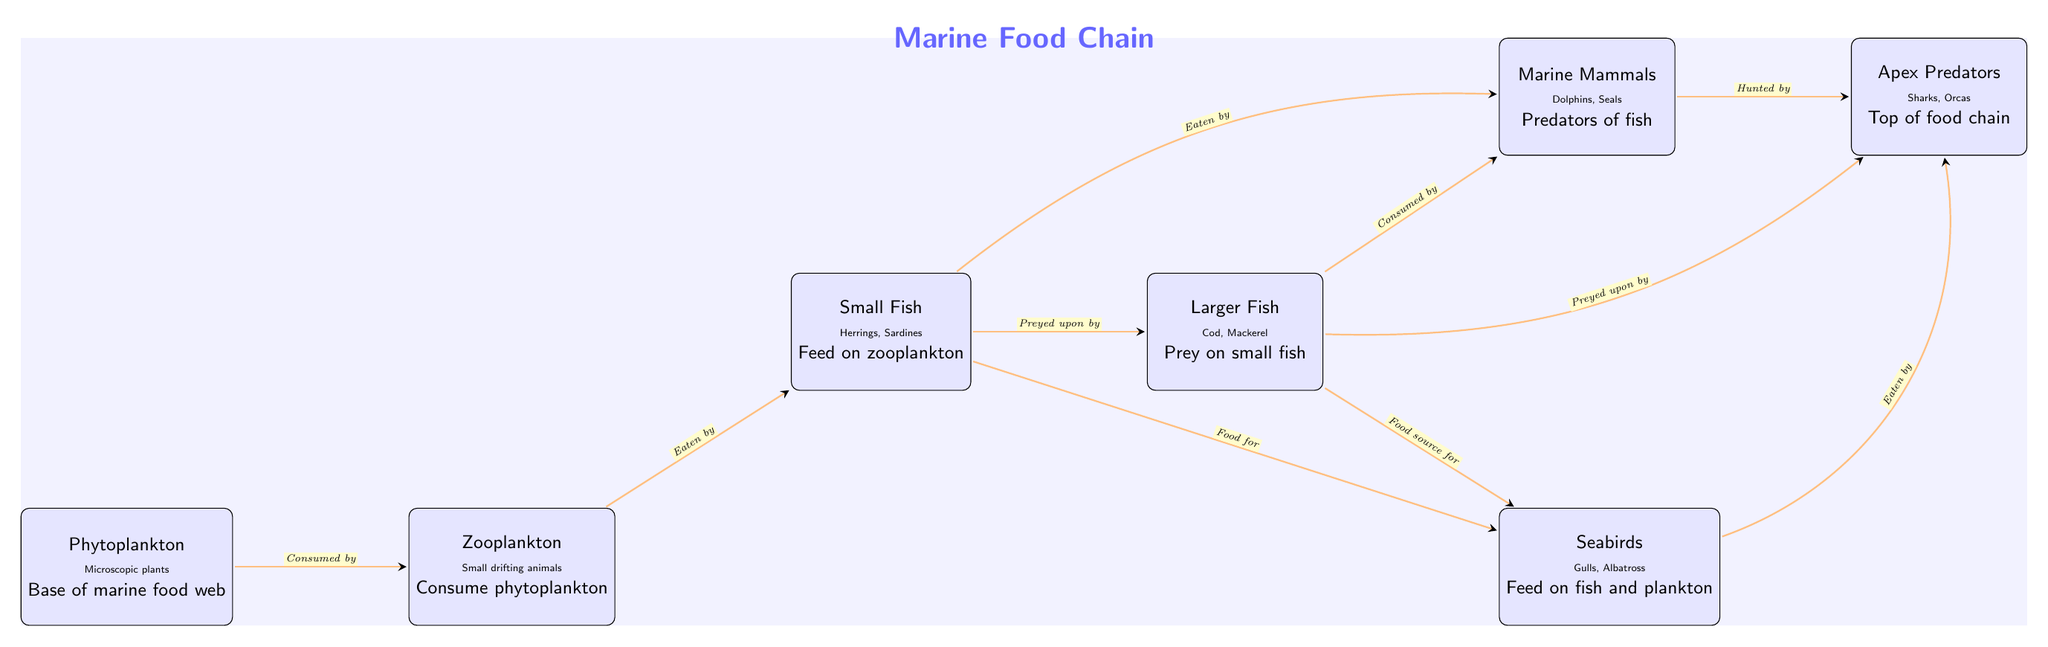What is the base of the marine food web? The diagram indicates that phytoplankton is at the base of the marine food web, as it is the first node listed in the food chain.
Answer: Phytoplankton Which group consumes zooplankton? According to the diagram, small fish are indicated as the group that consumes zooplankton, as shown by the arrow pointing from zooplankton to small fish.
Answer: Small Fish Who are the apex predators in this food chain? The diagram labels apex predators at the rightmost position, indicating that sharks and orcas are at the top of the food chain.
Answer: Sharks, Orcas How many main groups are in the marine food chain? The diagram displays a total of seven main groups, from phytoplankton to apex predators, all represented as nodes.
Answer: Seven What is the relationship between larger fish and marine mammals? The diagram shows that larger fish are consumed by marine mammals, as indicated by the arrow pointing from larger fish to marine mammals.
Answer: Consumed by Which groups feed on small fish? From the diagram, both larger fish and seabirds are noted as groups that feed on small fish, which is represented by the arrows pointing towards larger fish and seabirds.
Answer: Larger Fish, Seabirds Do marine mammals eat phytoplankton? The diagram does not indicate a direct relationship where marine mammals eat phytoplankton, as they primarily interact with small fish and larger fish in the food chain.
Answer: No What serves as food for apex predators? According to the diagram, apex predators have multiple food sources including marine mammals, larger fish, and seabirds, as shown by the arrows pointing towards apex predators.
Answer: Marine Mammals, Larger Fish, Seabirds 